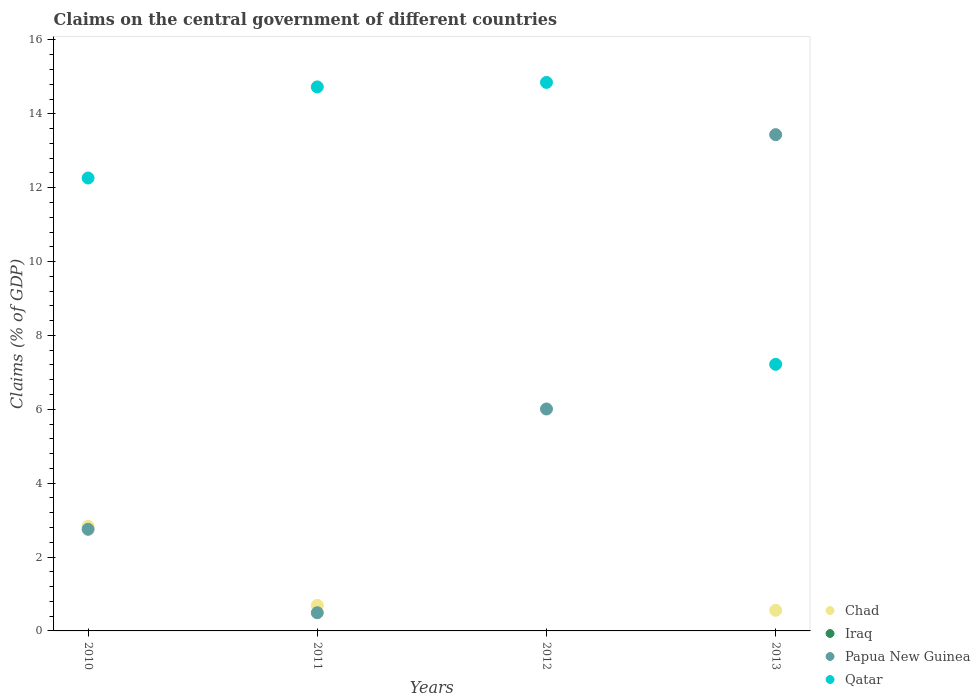What is the percentage of GDP claimed on the central government in Chad in 2012?
Provide a short and direct response. 0. Across all years, what is the maximum percentage of GDP claimed on the central government in Chad?
Provide a succinct answer. 2.83. Across all years, what is the minimum percentage of GDP claimed on the central government in Qatar?
Your answer should be compact. 7.22. In which year was the percentage of GDP claimed on the central government in Chad maximum?
Provide a succinct answer. 2010. What is the difference between the percentage of GDP claimed on the central government in Qatar in 2010 and that in 2011?
Keep it short and to the point. -2.47. What is the difference between the percentage of GDP claimed on the central government in Iraq in 2011 and the percentage of GDP claimed on the central government in Papua New Guinea in 2010?
Make the answer very short. -2.75. What is the average percentage of GDP claimed on the central government in Qatar per year?
Your response must be concise. 12.26. In the year 2013, what is the difference between the percentage of GDP claimed on the central government in Chad and percentage of GDP claimed on the central government in Qatar?
Your answer should be compact. -6.66. What is the ratio of the percentage of GDP claimed on the central government in Qatar in 2010 to that in 2012?
Ensure brevity in your answer.  0.83. Is the percentage of GDP claimed on the central government in Papua New Guinea in 2010 less than that in 2013?
Your response must be concise. Yes. What is the difference between the highest and the second highest percentage of GDP claimed on the central government in Qatar?
Your answer should be very brief. 0.12. What is the difference between the highest and the lowest percentage of GDP claimed on the central government in Chad?
Ensure brevity in your answer.  2.83. In how many years, is the percentage of GDP claimed on the central government in Iraq greater than the average percentage of GDP claimed on the central government in Iraq taken over all years?
Give a very brief answer. 0. Is the percentage of GDP claimed on the central government in Papua New Guinea strictly greater than the percentage of GDP claimed on the central government in Chad over the years?
Provide a succinct answer. No. How many dotlines are there?
Provide a succinct answer. 3. What is the difference between two consecutive major ticks on the Y-axis?
Give a very brief answer. 2. Are the values on the major ticks of Y-axis written in scientific E-notation?
Provide a short and direct response. No. How are the legend labels stacked?
Provide a short and direct response. Vertical. What is the title of the graph?
Make the answer very short. Claims on the central government of different countries. What is the label or title of the X-axis?
Make the answer very short. Years. What is the label or title of the Y-axis?
Provide a short and direct response. Claims (% of GDP). What is the Claims (% of GDP) in Chad in 2010?
Give a very brief answer. 2.83. What is the Claims (% of GDP) of Papua New Guinea in 2010?
Give a very brief answer. 2.75. What is the Claims (% of GDP) in Qatar in 2010?
Offer a very short reply. 12.26. What is the Claims (% of GDP) of Chad in 2011?
Provide a short and direct response. 0.69. What is the Claims (% of GDP) in Iraq in 2011?
Your response must be concise. 0. What is the Claims (% of GDP) of Papua New Guinea in 2011?
Make the answer very short. 0.49. What is the Claims (% of GDP) of Qatar in 2011?
Provide a short and direct response. 14.73. What is the Claims (% of GDP) in Chad in 2012?
Ensure brevity in your answer.  0. What is the Claims (% of GDP) of Papua New Guinea in 2012?
Ensure brevity in your answer.  6.01. What is the Claims (% of GDP) of Qatar in 2012?
Give a very brief answer. 14.85. What is the Claims (% of GDP) in Chad in 2013?
Offer a terse response. 0.56. What is the Claims (% of GDP) of Papua New Guinea in 2013?
Offer a very short reply. 13.44. What is the Claims (% of GDP) of Qatar in 2013?
Your response must be concise. 7.22. Across all years, what is the maximum Claims (% of GDP) in Chad?
Your response must be concise. 2.83. Across all years, what is the maximum Claims (% of GDP) in Papua New Guinea?
Keep it short and to the point. 13.44. Across all years, what is the maximum Claims (% of GDP) of Qatar?
Ensure brevity in your answer.  14.85. Across all years, what is the minimum Claims (% of GDP) of Papua New Guinea?
Your response must be concise. 0.49. Across all years, what is the minimum Claims (% of GDP) in Qatar?
Keep it short and to the point. 7.22. What is the total Claims (% of GDP) of Chad in the graph?
Your answer should be very brief. 4.08. What is the total Claims (% of GDP) in Papua New Guinea in the graph?
Offer a very short reply. 22.69. What is the total Claims (% of GDP) of Qatar in the graph?
Ensure brevity in your answer.  49.06. What is the difference between the Claims (% of GDP) of Chad in 2010 and that in 2011?
Keep it short and to the point. 2.14. What is the difference between the Claims (% of GDP) of Papua New Guinea in 2010 and that in 2011?
Offer a terse response. 2.26. What is the difference between the Claims (% of GDP) of Qatar in 2010 and that in 2011?
Your response must be concise. -2.47. What is the difference between the Claims (% of GDP) in Papua New Guinea in 2010 and that in 2012?
Make the answer very short. -3.26. What is the difference between the Claims (% of GDP) of Qatar in 2010 and that in 2012?
Your response must be concise. -2.59. What is the difference between the Claims (% of GDP) of Chad in 2010 and that in 2013?
Offer a very short reply. 2.27. What is the difference between the Claims (% of GDP) of Papua New Guinea in 2010 and that in 2013?
Ensure brevity in your answer.  -10.68. What is the difference between the Claims (% of GDP) in Qatar in 2010 and that in 2013?
Keep it short and to the point. 5.04. What is the difference between the Claims (% of GDP) of Papua New Guinea in 2011 and that in 2012?
Your answer should be compact. -5.52. What is the difference between the Claims (% of GDP) in Qatar in 2011 and that in 2012?
Your answer should be very brief. -0.12. What is the difference between the Claims (% of GDP) of Chad in 2011 and that in 2013?
Your response must be concise. 0.13. What is the difference between the Claims (% of GDP) in Papua New Guinea in 2011 and that in 2013?
Ensure brevity in your answer.  -12.94. What is the difference between the Claims (% of GDP) of Qatar in 2011 and that in 2013?
Keep it short and to the point. 7.51. What is the difference between the Claims (% of GDP) in Papua New Guinea in 2012 and that in 2013?
Offer a terse response. -7.43. What is the difference between the Claims (% of GDP) in Qatar in 2012 and that in 2013?
Provide a short and direct response. 7.63. What is the difference between the Claims (% of GDP) of Chad in 2010 and the Claims (% of GDP) of Papua New Guinea in 2011?
Offer a terse response. 2.34. What is the difference between the Claims (% of GDP) of Chad in 2010 and the Claims (% of GDP) of Qatar in 2011?
Your answer should be very brief. -11.9. What is the difference between the Claims (% of GDP) of Papua New Guinea in 2010 and the Claims (% of GDP) of Qatar in 2011?
Make the answer very short. -11.98. What is the difference between the Claims (% of GDP) in Chad in 2010 and the Claims (% of GDP) in Papua New Guinea in 2012?
Give a very brief answer. -3.18. What is the difference between the Claims (% of GDP) of Chad in 2010 and the Claims (% of GDP) of Qatar in 2012?
Offer a very short reply. -12.02. What is the difference between the Claims (% of GDP) of Papua New Guinea in 2010 and the Claims (% of GDP) of Qatar in 2012?
Your answer should be very brief. -12.1. What is the difference between the Claims (% of GDP) in Chad in 2010 and the Claims (% of GDP) in Papua New Guinea in 2013?
Offer a very short reply. -10.6. What is the difference between the Claims (% of GDP) in Chad in 2010 and the Claims (% of GDP) in Qatar in 2013?
Offer a very short reply. -4.39. What is the difference between the Claims (% of GDP) in Papua New Guinea in 2010 and the Claims (% of GDP) in Qatar in 2013?
Make the answer very short. -4.47. What is the difference between the Claims (% of GDP) in Chad in 2011 and the Claims (% of GDP) in Papua New Guinea in 2012?
Make the answer very short. -5.32. What is the difference between the Claims (% of GDP) in Chad in 2011 and the Claims (% of GDP) in Qatar in 2012?
Offer a terse response. -14.16. What is the difference between the Claims (% of GDP) of Papua New Guinea in 2011 and the Claims (% of GDP) of Qatar in 2012?
Your response must be concise. -14.36. What is the difference between the Claims (% of GDP) in Chad in 2011 and the Claims (% of GDP) in Papua New Guinea in 2013?
Provide a short and direct response. -12.75. What is the difference between the Claims (% of GDP) of Chad in 2011 and the Claims (% of GDP) of Qatar in 2013?
Offer a terse response. -6.53. What is the difference between the Claims (% of GDP) of Papua New Guinea in 2011 and the Claims (% of GDP) of Qatar in 2013?
Offer a terse response. -6.73. What is the difference between the Claims (% of GDP) in Papua New Guinea in 2012 and the Claims (% of GDP) in Qatar in 2013?
Provide a succinct answer. -1.21. What is the average Claims (% of GDP) in Iraq per year?
Make the answer very short. 0. What is the average Claims (% of GDP) in Papua New Guinea per year?
Ensure brevity in your answer.  5.67. What is the average Claims (% of GDP) in Qatar per year?
Your answer should be compact. 12.26. In the year 2010, what is the difference between the Claims (% of GDP) of Chad and Claims (% of GDP) of Papua New Guinea?
Ensure brevity in your answer.  0.08. In the year 2010, what is the difference between the Claims (% of GDP) of Chad and Claims (% of GDP) of Qatar?
Your response must be concise. -9.43. In the year 2010, what is the difference between the Claims (% of GDP) of Papua New Guinea and Claims (% of GDP) of Qatar?
Make the answer very short. -9.51. In the year 2011, what is the difference between the Claims (% of GDP) of Chad and Claims (% of GDP) of Papua New Guinea?
Keep it short and to the point. 0.2. In the year 2011, what is the difference between the Claims (% of GDP) in Chad and Claims (% of GDP) in Qatar?
Make the answer very short. -14.04. In the year 2011, what is the difference between the Claims (% of GDP) in Papua New Guinea and Claims (% of GDP) in Qatar?
Give a very brief answer. -14.24. In the year 2012, what is the difference between the Claims (% of GDP) in Papua New Guinea and Claims (% of GDP) in Qatar?
Give a very brief answer. -8.84. In the year 2013, what is the difference between the Claims (% of GDP) of Chad and Claims (% of GDP) of Papua New Guinea?
Give a very brief answer. -12.88. In the year 2013, what is the difference between the Claims (% of GDP) in Chad and Claims (% of GDP) in Qatar?
Your answer should be very brief. -6.66. In the year 2013, what is the difference between the Claims (% of GDP) of Papua New Guinea and Claims (% of GDP) of Qatar?
Offer a very short reply. 6.22. What is the ratio of the Claims (% of GDP) of Chad in 2010 to that in 2011?
Your answer should be compact. 4.1. What is the ratio of the Claims (% of GDP) of Papua New Guinea in 2010 to that in 2011?
Your answer should be very brief. 5.59. What is the ratio of the Claims (% of GDP) of Qatar in 2010 to that in 2011?
Keep it short and to the point. 0.83. What is the ratio of the Claims (% of GDP) in Papua New Guinea in 2010 to that in 2012?
Offer a very short reply. 0.46. What is the ratio of the Claims (% of GDP) of Qatar in 2010 to that in 2012?
Your answer should be very brief. 0.83. What is the ratio of the Claims (% of GDP) of Chad in 2010 to that in 2013?
Offer a terse response. 5.07. What is the ratio of the Claims (% of GDP) of Papua New Guinea in 2010 to that in 2013?
Your answer should be very brief. 0.2. What is the ratio of the Claims (% of GDP) in Qatar in 2010 to that in 2013?
Ensure brevity in your answer.  1.7. What is the ratio of the Claims (% of GDP) of Papua New Guinea in 2011 to that in 2012?
Make the answer very short. 0.08. What is the ratio of the Claims (% of GDP) in Chad in 2011 to that in 2013?
Make the answer very short. 1.24. What is the ratio of the Claims (% of GDP) of Papua New Guinea in 2011 to that in 2013?
Provide a short and direct response. 0.04. What is the ratio of the Claims (% of GDP) of Qatar in 2011 to that in 2013?
Keep it short and to the point. 2.04. What is the ratio of the Claims (% of GDP) in Papua New Guinea in 2012 to that in 2013?
Offer a terse response. 0.45. What is the ratio of the Claims (% of GDP) in Qatar in 2012 to that in 2013?
Offer a terse response. 2.06. What is the difference between the highest and the second highest Claims (% of GDP) in Chad?
Your answer should be very brief. 2.14. What is the difference between the highest and the second highest Claims (% of GDP) in Papua New Guinea?
Provide a succinct answer. 7.43. What is the difference between the highest and the second highest Claims (% of GDP) in Qatar?
Offer a very short reply. 0.12. What is the difference between the highest and the lowest Claims (% of GDP) in Chad?
Your answer should be compact. 2.83. What is the difference between the highest and the lowest Claims (% of GDP) in Papua New Guinea?
Provide a short and direct response. 12.94. What is the difference between the highest and the lowest Claims (% of GDP) of Qatar?
Keep it short and to the point. 7.63. 